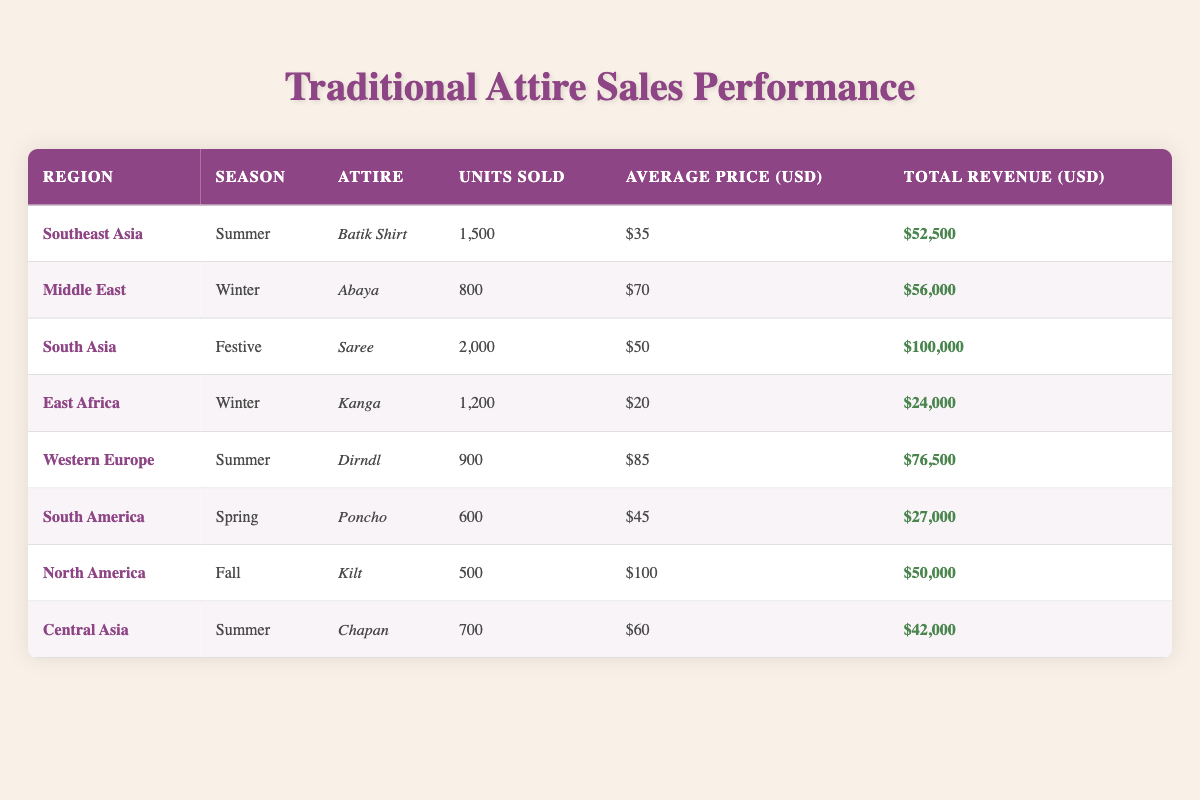What is the total revenue from the sale of Batik Shirts in Southeast Asia? The table lists that 1,500 units of Batik Shirts were sold at an average price of 35 USD each. To find the total revenue, multiply the units sold by the average price: 1,500 * 35 = 52,500 USD.
Answer: 52,500 USD How many units of Sarees were sold during the Festive season in South Asia? From the table, it shows that 2,000 units of Sarees were sold in South Asia during the Festive season.
Answer: 2,000 units Which attire sold the most units overall? Looking through the units sold for each attire, the Saree has the highest sales at 2,000 units, compared to others like Batik Shirt (1,500) and Kanga (1,200).
Answer: Saree What is the average price of the Kilt in North America? The table specifies that the average price of the Kilt in North America is 100 USD.
Answer: 100 USD Which region reported the highest total revenue for traditional attire in the Summer season? In the table, the total revenues for the Summer season are: Southeast Asia (52,500 USD) and Western Europe (76,500 USD). Since 76,500 USD is greater than 52,500 USD, the region with the highest total revenue in Summer is Western Europe.
Answer: Western Europe Is it true that the average price of the Abaya in the Middle East is higher than that of the Kanga in East Africa? The average price of the Abaya is 70 USD, and for the Kanga, it is 20 USD. Since 70 is greater than 20, it is indeed true.
Answer: Yes What is the total number of units sold across all regions for the Spring season? Referring to the table, the only attire sold in Spring is the Poncho, with 600 units sold. Therefore, the total number of units sold in the Spring season is 600.
Answer: 600 units Which two regions have sales reported in the Winter season, and how do their total revenues compare? The table shows sales in the Winter season for the Middle East with a total revenue of 56,000 USD from 800 Abayas, and East Africa with 24,000 USD from 1,200 Kangas. Comparing these, 56,000 is higher than 24,000, indicating that the Middle East has higher total revenue in Winter.
Answer: Middle East has higher revenue 